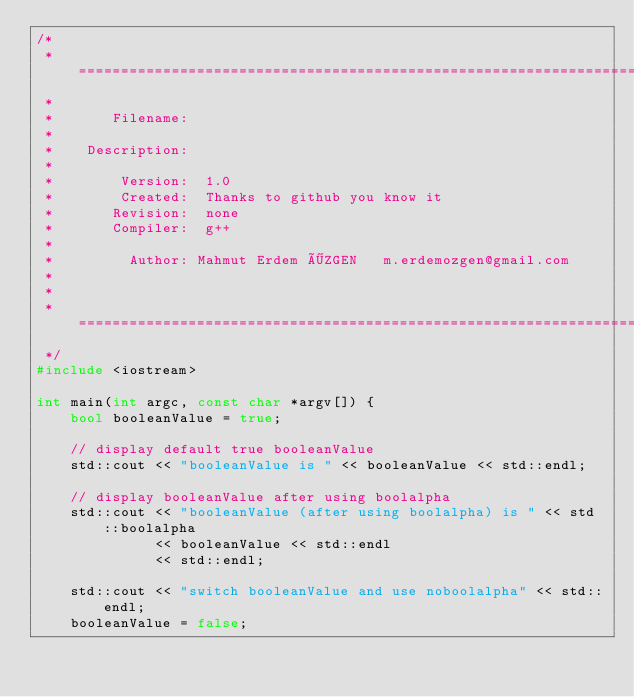Convert code to text. <code><loc_0><loc_0><loc_500><loc_500><_C++_>/*
 * =====================================================================================
 *
 *       Filename:  
 *
 *    Description:  
 *
 *        Version:  1.0
 *        Created:  Thanks to github you know it
 *       Revision:  none
 *       Compiler:  g++
 *
 *         Author: Mahmut Erdem ÖZGEN   m.erdemozgen@gmail.com
 *   
 *
 * =====================================================================================
 */
#include <iostream>

int main(int argc, const char *argv[]) {
    bool booleanValue = true;

    // display default true booleanValue
    std::cout << "booleanValue is " << booleanValue << std::endl;

    // display booleanValue after using boolalpha
    std::cout << "booleanValue (after using boolalpha) is " << std::boolalpha
              << booleanValue << std::endl
              << std::endl;

    std::cout << "switch booleanValue and use noboolalpha" << std::endl;
    booleanValue = false;</code> 